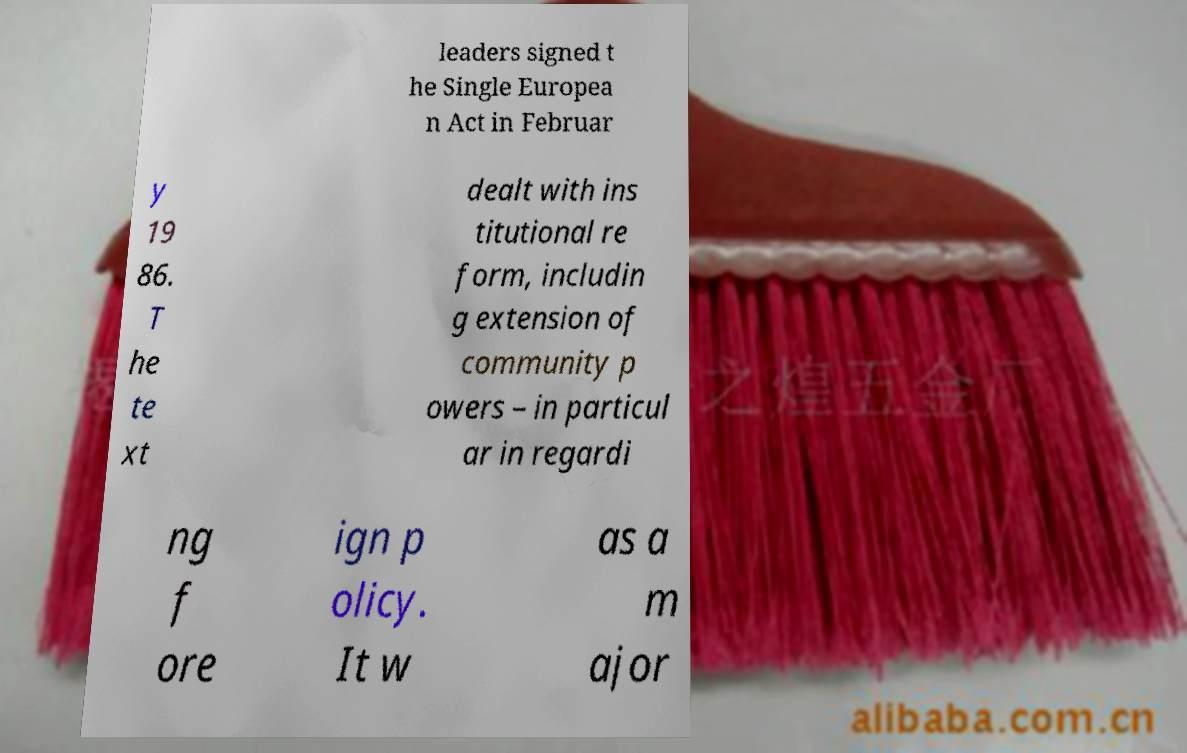Please identify and transcribe the text found in this image. leaders signed t he Single Europea n Act in Februar y 19 86. T he te xt dealt with ins titutional re form, includin g extension of community p owers – in particul ar in regardi ng f ore ign p olicy. It w as a m ajor 